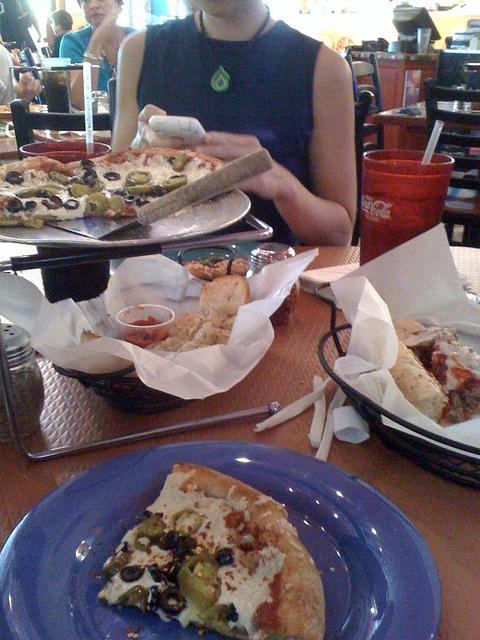What is in the thing with coke?

Choices:
A) fork
B) straw
C) pencil
D) spoon straw 